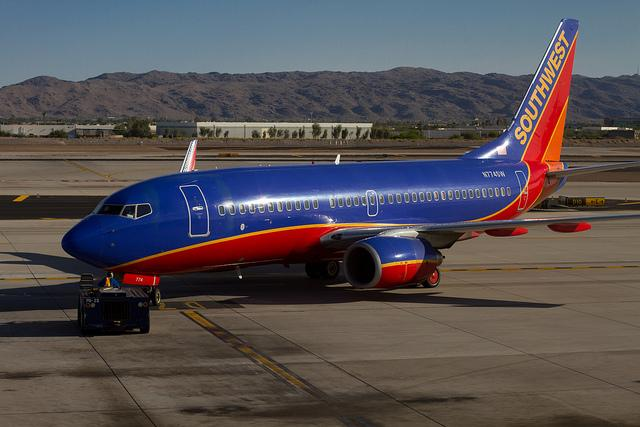Where is the plane stopped?

Choices:
A) road
B) driveway
C) tarmac
D) roof top tarmac 